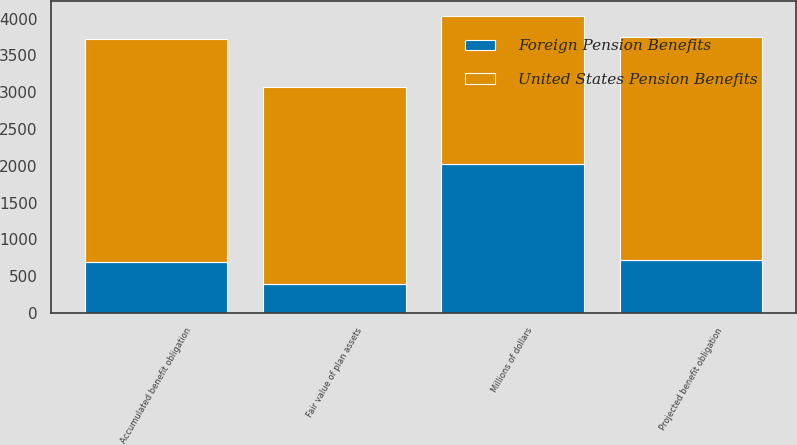Convert chart. <chart><loc_0><loc_0><loc_500><loc_500><stacked_bar_chart><ecel><fcel>Millions of dollars<fcel>Projected benefit obligation<fcel>Accumulated benefit obligation<fcel>Fair value of plan assets<nl><fcel>United States Pension Benefits<fcel>2018<fcel>3033<fcel>3022<fcel>2676<nl><fcel>Foreign Pension Benefits<fcel>2018<fcel>720<fcel>699<fcel>396<nl></chart> 